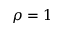Convert formula to latex. <formula><loc_0><loc_0><loc_500><loc_500>\rho = 1</formula> 